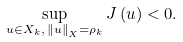<formula> <loc_0><loc_0><loc_500><loc_500>\sup _ { u \in X _ { k } , \, \left \| u \right \| _ { X } = \rho _ { k } } J \left ( u \right ) < 0 .</formula> 